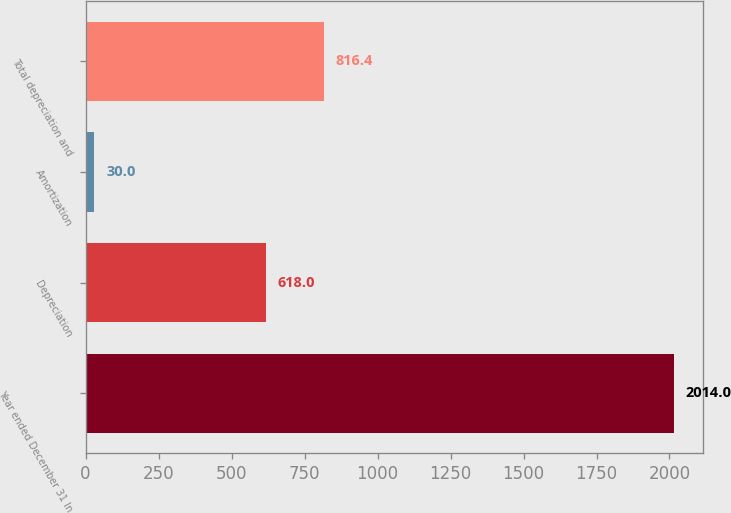Convert chart to OTSL. <chart><loc_0><loc_0><loc_500><loc_500><bar_chart><fcel>Year ended December 31 In<fcel>Depreciation<fcel>Amortization<fcel>Total depreciation and<nl><fcel>2014<fcel>618<fcel>30<fcel>816.4<nl></chart> 